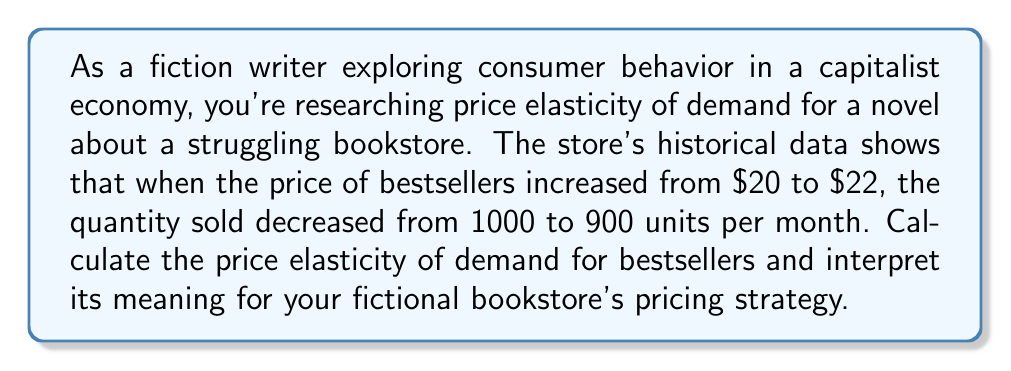Solve this math problem. To calculate the price elasticity of demand, we'll use the midpoint formula:

1) The formula for price elasticity of demand is:

   $$E_d = \frac{\text{Percentage change in quantity}}{\text{Percentage change in price}}$$

2) Using the midpoint formula:

   $$E_d = \frac{(Q_2 - Q_1) / [(Q_1 + Q_2) / 2]}{(P_2 - P_1) / [(P_1 + P_2) / 2]}$$

3) Given:
   $Q_1 = 1000$, $Q_2 = 900$
   $P_1 = 20$, $P_2 = 22$

4) Calculate percentage change in quantity:
   $$\frac{900 - 1000}{(1000 + 900) / 2} = \frac{-100}{950} = -0.1053$$

5) Calculate percentage change in price:
   $$\frac{22 - 20}{(20 + 22) / 2} = \frac{2}{21} = 0.0952$$

6) Calculate price elasticity of demand:
   $$E_d = \frac{-0.1053}{0.0952} = -1.106$$

7) Interpretation:
   The absolute value of $E_d$ is greater than 1, indicating that demand is elastic. This means consumers are sensitive to price changes. For every 1% increase in price, there's a 1.106% decrease in quantity demanded.

For the fictional bookstore, this suggests that raising prices might lead to a more than proportional decrease in sales, potentially reducing overall revenue. The store might consider keeping prices stable or exploring non-price competition strategies to maintain sales volume.
Answer: $E_d = -1.106$, elastic demand 